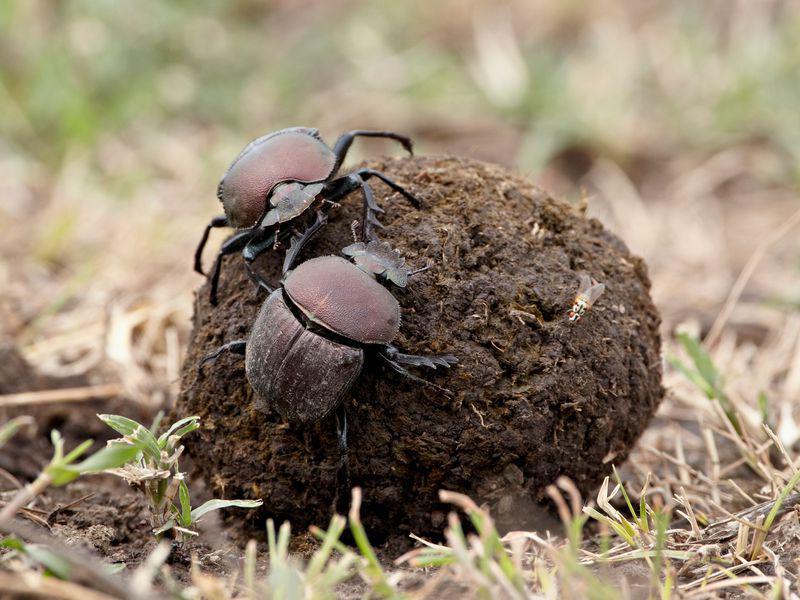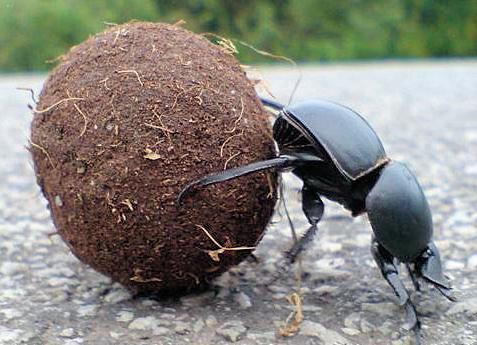The first image is the image on the left, the second image is the image on the right. Evaluate the accuracy of this statement regarding the images: "The image on the left shows two beetles on top of a dungball.". Is it true? Answer yes or no. Yes. 